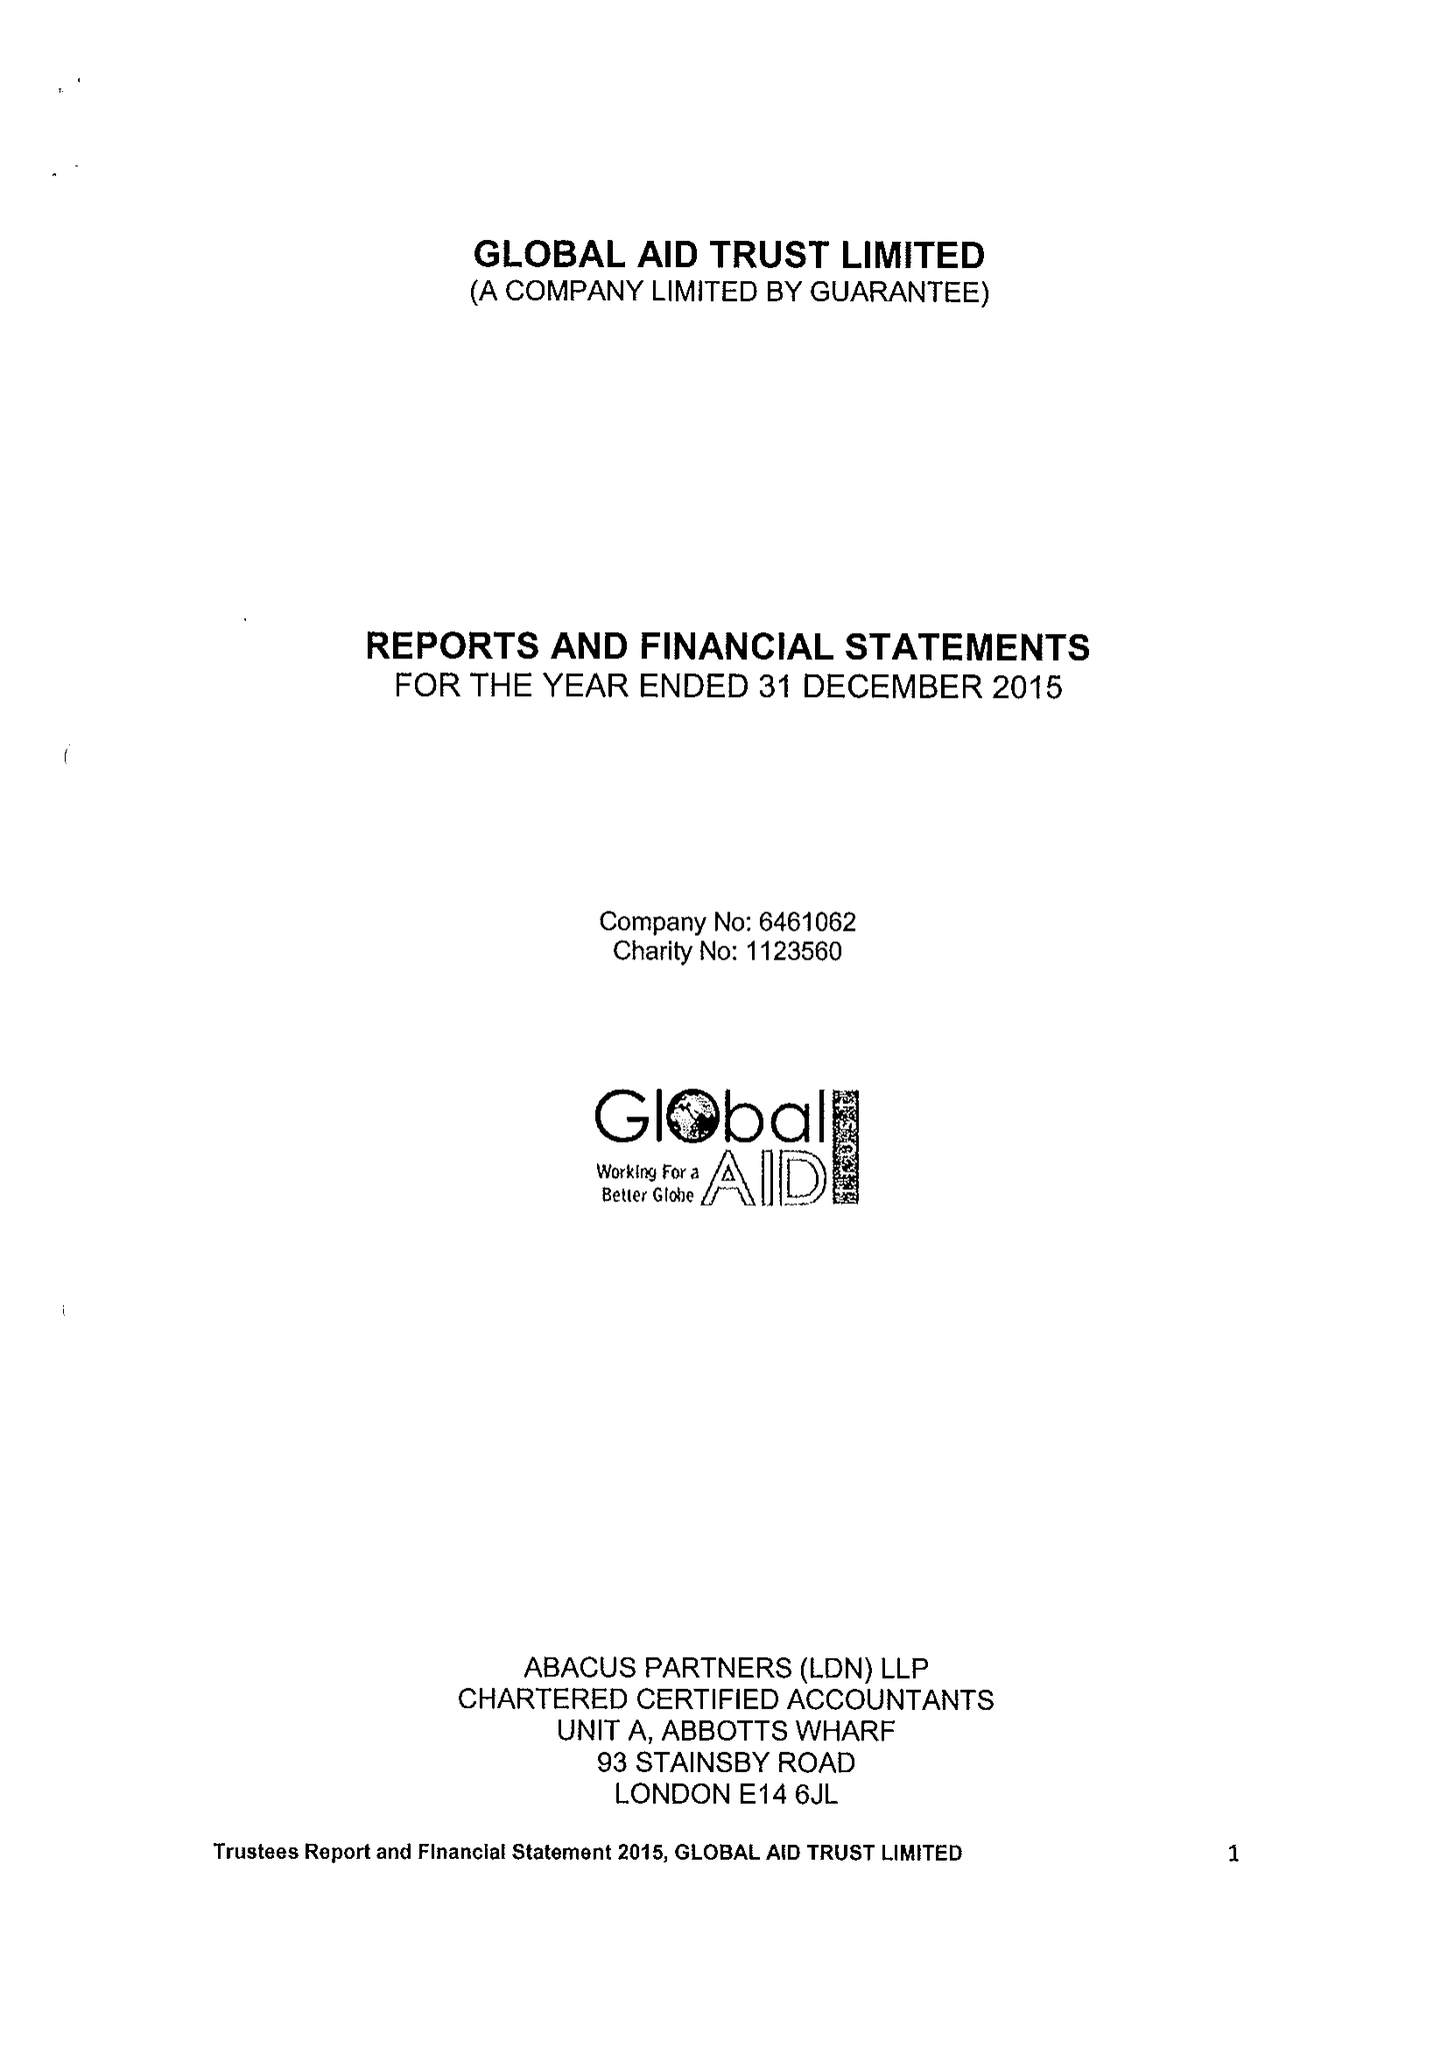What is the value for the report_date?
Answer the question using a single word or phrase. 2015-12-31 